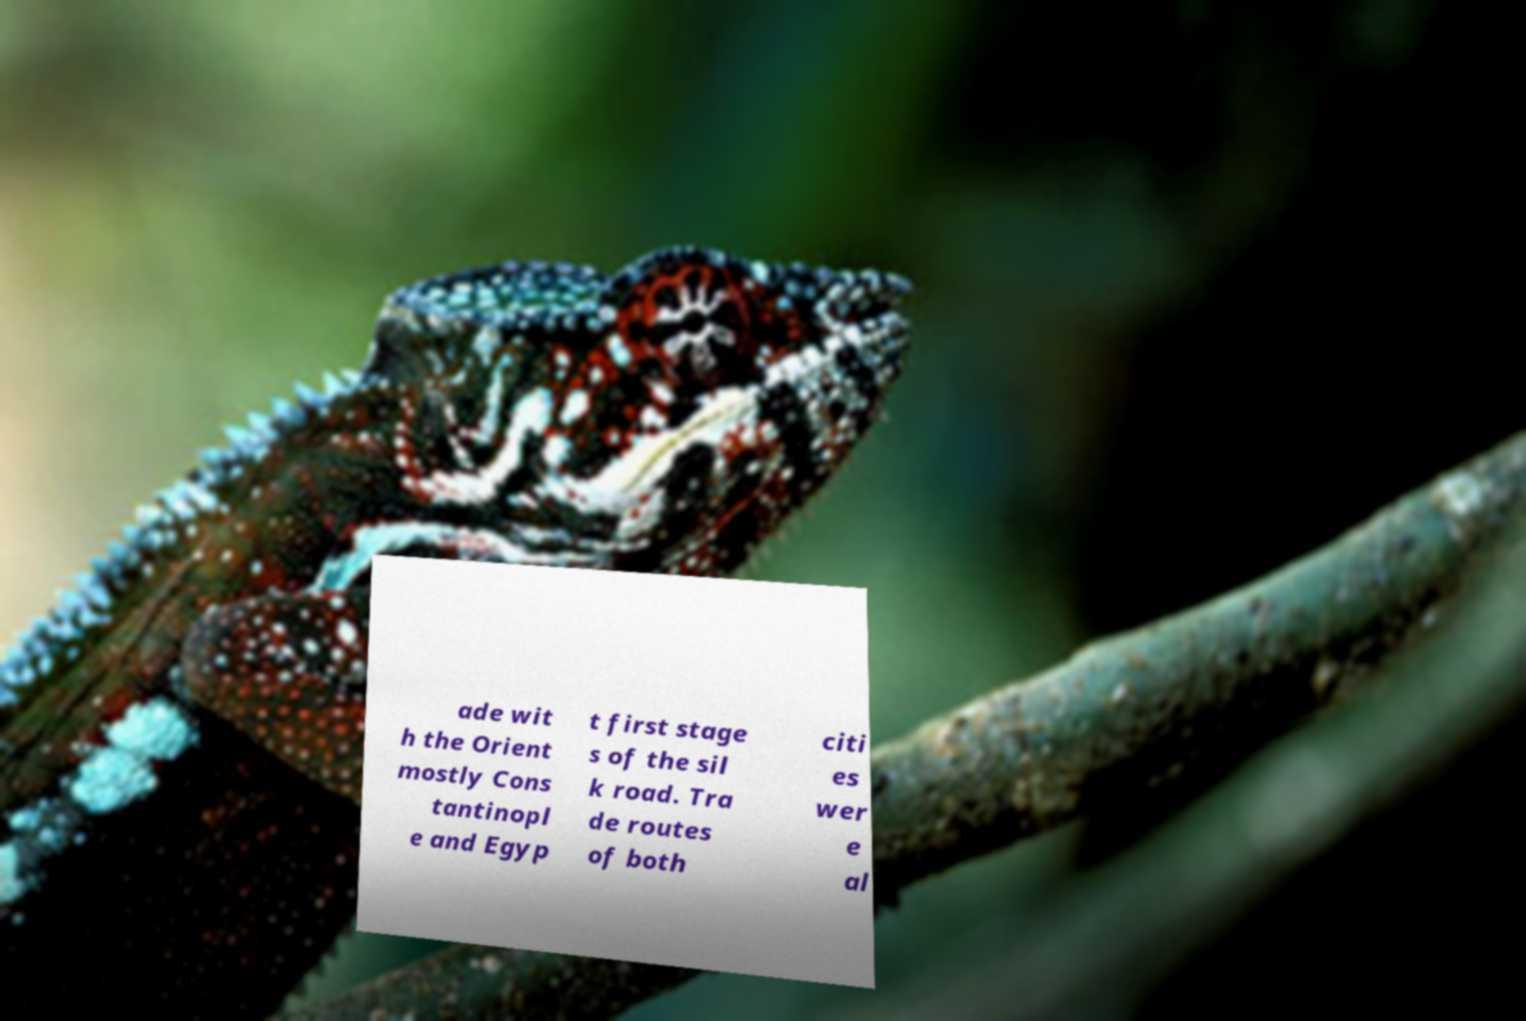I need the written content from this picture converted into text. Can you do that? ade wit h the Orient mostly Cons tantinopl e and Egyp t first stage s of the sil k road. Tra de routes of both citi es wer e al 